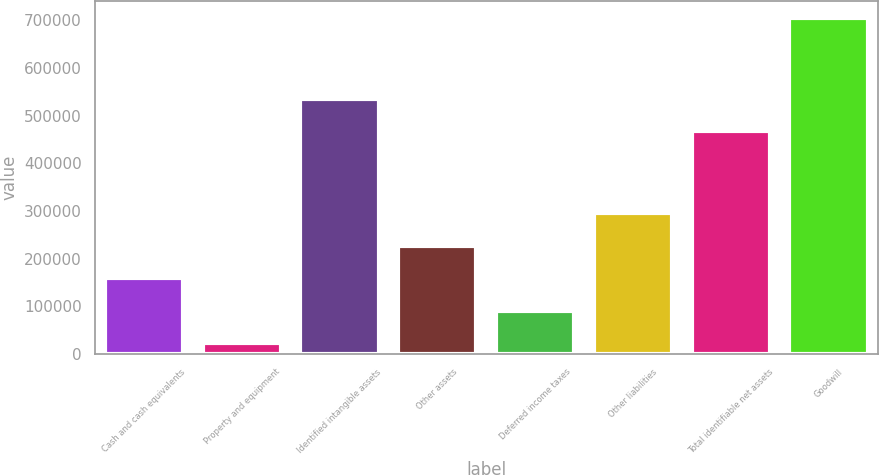Convert chart. <chart><loc_0><loc_0><loc_500><loc_500><bar_chart><fcel>Cash and cash equivalents<fcel>Property and equipment<fcel>Identified intangible assets<fcel>Other assets<fcel>Deferred income taxes<fcel>Other liabilities<fcel>Total identifiable net assets<fcel>Goodwill<nl><fcel>159115<fcel>22889<fcel>535669<fcel>227228<fcel>91002.1<fcel>295341<fcel>467556<fcel>704020<nl></chart> 